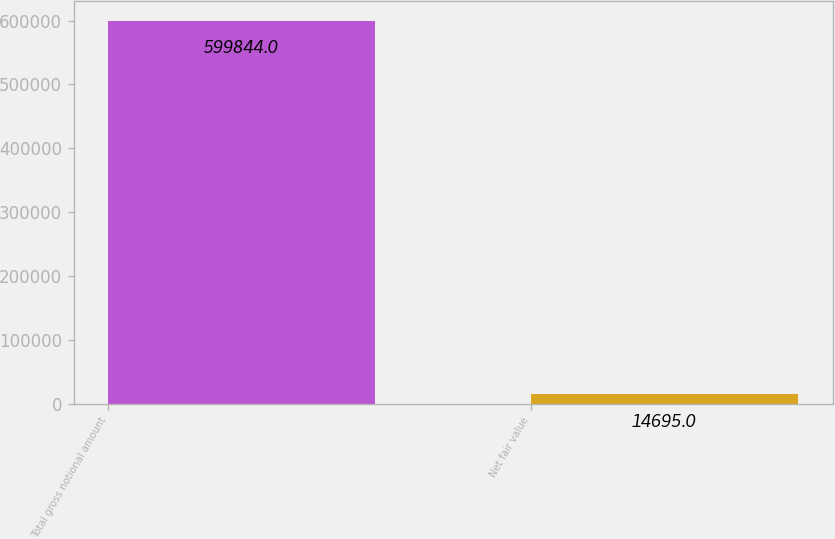Convert chart. <chart><loc_0><loc_0><loc_500><loc_500><bar_chart><fcel>Total gross notional amount<fcel>Net fair value<nl><fcel>599844<fcel>14695<nl></chart> 